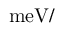Convert formula to latex. <formula><loc_0><loc_0><loc_500><loc_500>m e V / \AA</formula> 